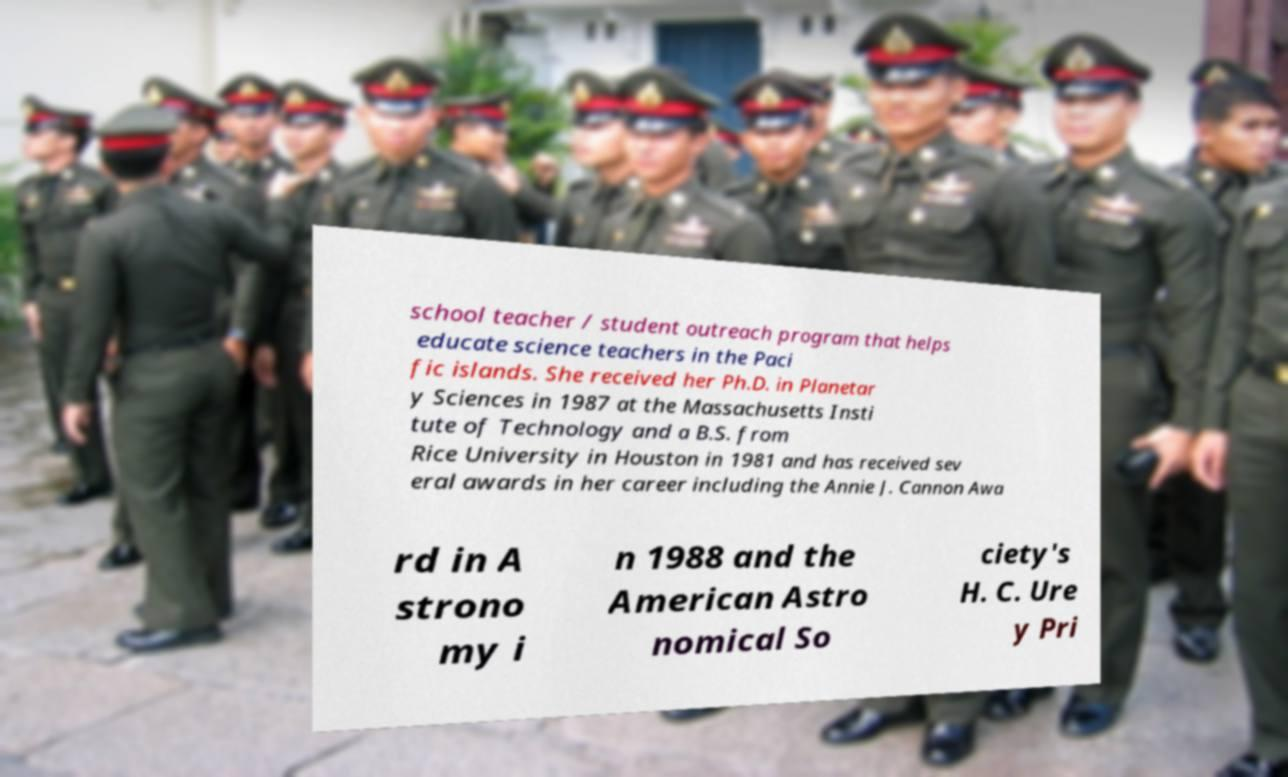For documentation purposes, I need the text within this image transcribed. Could you provide that? school teacher / student outreach program that helps educate science teachers in the Paci fic islands. She received her Ph.D. in Planetar y Sciences in 1987 at the Massachusetts Insti tute of Technology and a B.S. from Rice University in Houston in 1981 and has received sev eral awards in her career including the Annie J. Cannon Awa rd in A strono my i n 1988 and the American Astro nomical So ciety's H. C. Ure y Pri 